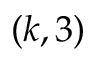Convert formula to latex. <formula><loc_0><loc_0><loc_500><loc_500>( k , 3 )</formula> 